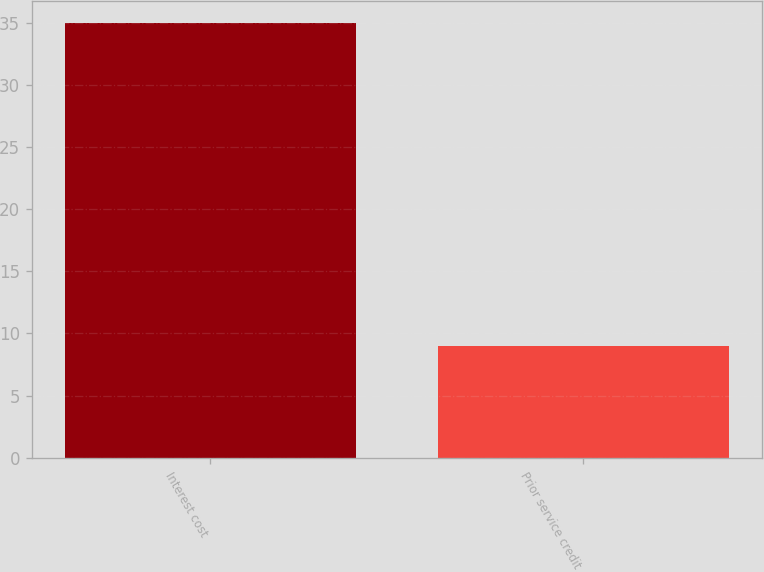Convert chart. <chart><loc_0><loc_0><loc_500><loc_500><bar_chart><fcel>Interest cost<fcel>Prior service credit<nl><fcel>35<fcel>9<nl></chart> 